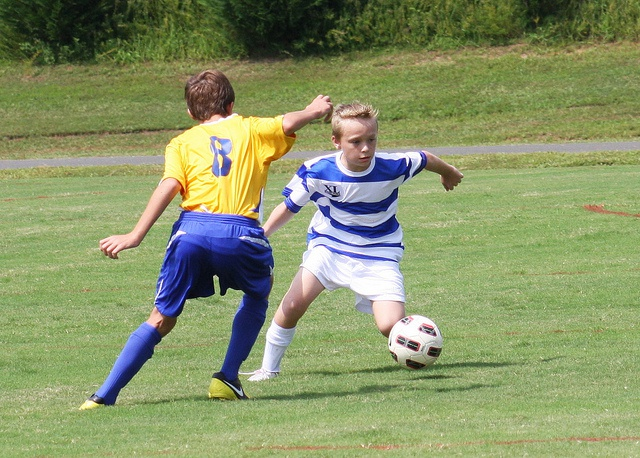Describe the objects in this image and their specific colors. I can see people in darkgreen, khaki, navy, and black tones, people in darkgreen, lavender, darkgray, and navy tones, and sports ball in darkgreen, white, darkgray, black, and olive tones in this image. 